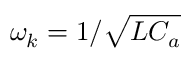Convert formula to latex. <formula><loc_0><loc_0><loc_500><loc_500>\omega _ { k } = 1 / \sqrt { L C _ { a } }</formula> 